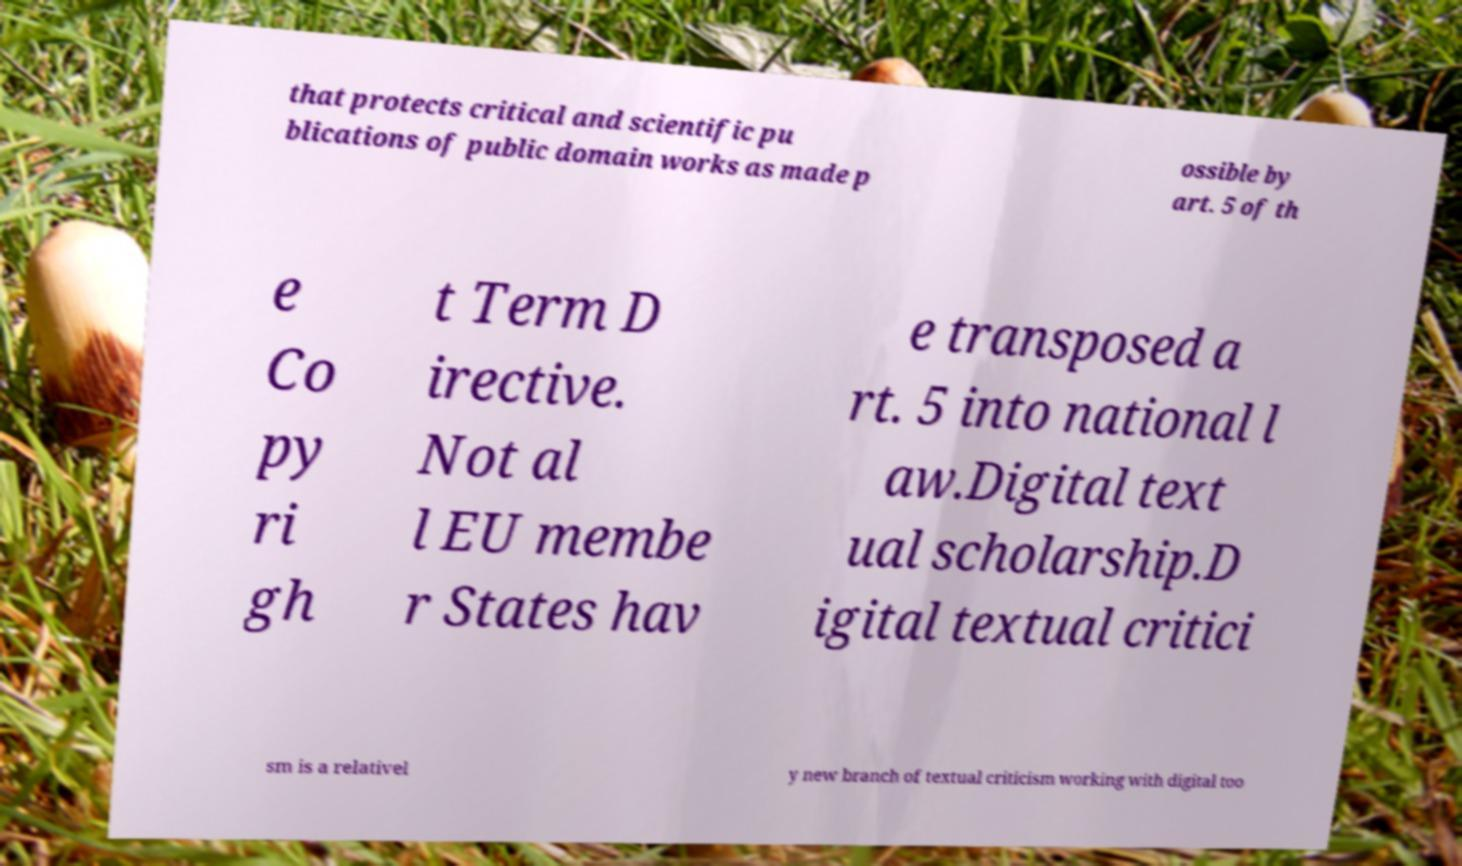Can you accurately transcribe the text from the provided image for me? that protects critical and scientific pu blications of public domain works as made p ossible by art. 5 of th e Co py ri gh t Term D irective. Not al l EU membe r States hav e transposed a rt. 5 into national l aw.Digital text ual scholarship.D igital textual critici sm is a relativel y new branch of textual criticism working with digital too 